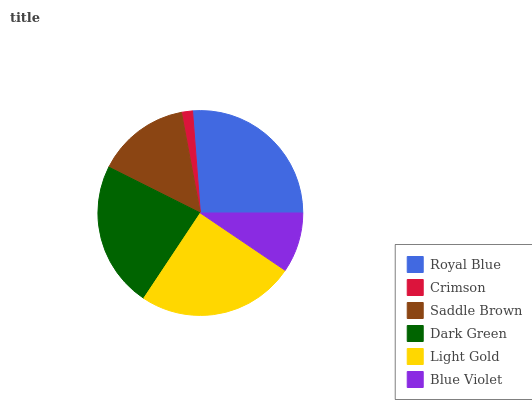Is Crimson the minimum?
Answer yes or no. Yes. Is Royal Blue the maximum?
Answer yes or no. Yes. Is Saddle Brown the minimum?
Answer yes or no. No. Is Saddle Brown the maximum?
Answer yes or no. No. Is Saddle Brown greater than Crimson?
Answer yes or no. Yes. Is Crimson less than Saddle Brown?
Answer yes or no. Yes. Is Crimson greater than Saddle Brown?
Answer yes or no. No. Is Saddle Brown less than Crimson?
Answer yes or no. No. Is Dark Green the high median?
Answer yes or no. Yes. Is Saddle Brown the low median?
Answer yes or no. Yes. Is Crimson the high median?
Answer yes or no. No. Is Crimson the low median?
Answer yes or no. No. 